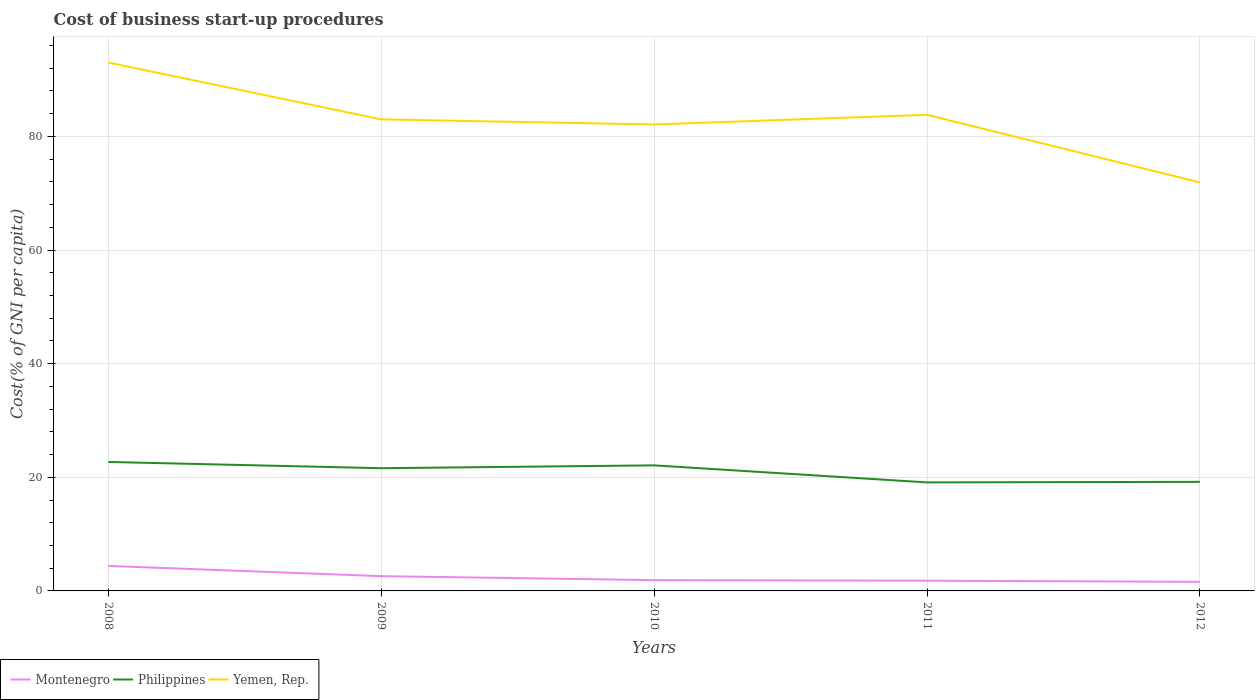Is the number of lines equal to the number of legend labels?
Make the answer very short. Yes. Across all years, what is the maximum cost of business start-up procedures in Philippines?
Your answer should be compact. 19.1. In which year was the cost of business start-up procedures in Philippines maximum?
Offer a terse response. 2011. What is the total cost of business start-up procedures in Montenegro in the graph?
Your response must be concise. 2.5. What is the difference between the highest and the second highest cost of business start-up procedures in Philippines?
Your response must be concise. 3.6. What is the difference between the highest and the lowest cost of business start-up procedures in Philippines?
Offer a very short reply. 3. How many lines are there?
Make the answer very short. 3. What is the difference between two consecutive major ticks on the Y-axis?
Make the answer very short. 20. Are the values on the major ticks of Y-axis written in scientific E-notation?
Make the answer very short. No. Does the graph contain grids?
Offer a terse response. Yes. Where does the legend appear in the graph?
Provide a succinct answer. Bottom left. How are the legend labels stacked?
Your answer should be very brief. Horizontal. What is the title of the graph?
Provide a succinct answer. Cost of business start-up procedures. What is the label or title of the Y-axis?
Offer a very short reply. Cost(% of GNI per capita). What is the Cost(% of GNI per capita) of Philippines in 2008?
Give a very brief answer. 22.7. What is the Cost(% of GNI per capita) in Yemen, Rep. in 2008?
Your response must be concise. 93. What is the Cost(% of GNI per capita) in Philippines in 2009?
Ensure brevity in your answer.  21.6. What is the Cost(% of GNI per capita) of Montenegro in 2010?
Your answer should be compact. 1.9. What is the Cost(% of GNI per capita) of Philippines in 2010?
Ensure brevity in your answer.  22.1. What is the Cost(% of GNI per capita) of Yemen, Rep. in 2010?
Give a very brief answer. 82.1. What is the Cost(% of GNI per capita) in Montenegro in 2011?
Provide a succinct answer. 1.8. What is the Cost(% of GNI per capita) of Philippines in 2011?
Your answer should be very brief. 19.1. What is the Cost(% of GNI per capita) in Yemen, Rep. in 2011?
Your answer should be very brief. 83.8. What is the Cost(% of GNI per capita) of Philippines in 2012?
Provide a succinct answer. 19.2. What is the Cost(% of GNI per capita) of Yemen, Rep. in 2012?
Give a very brief answer. 71.9. Across all years, what is the maximum Cost(% of GNI per capita) of Montenegro?
Your answer should be compact. 4.4. Across all years, what is the maximum Cost(% of GNI per capita) of Philippines?
Keep it short and to the point. 22.7. Across all years, what is the maximum Cost(% of GNI per capita) in Yemen, Rep.?
Provide a succinct answer. 93. Across all years, what is the minimum Cost(% of GNI per capita) of Montenegro?
Offer a very short reply. 1.6. Across all years, what is the minimum Cost(% of GNI per capita) in Yemen, Rep.?
Keep it short and to the point. 71.9. What is the total Cost(% of GNI per capita) of Montenegro in the graph?
Ensure brevity in your answer.  12.3. What is the total Cost(% of GNI per capita) in Philippines in the graph?
Ensure brevity in your answer.  104.7. What is the total Cost(% of GNI per capita) of Yemen, Rep. in the graph?
Your answer should be very brief. 413.8. What is the difference between the Cost(% of GNI per capita) in Yemen, Rep. in 2008 and that in 2010?
Make the answer very short. 10.9. What is the difference between the Cost(% of GNI per capita) in Philippines in 2008 and that in 2011?
Your answer should be compact. 3.6. What is the difference between the Cost(% of GNI per capita) of Yemen, Rep. in 2008 and that in 2011?
Provide a succinct answer. 9.2. What is the difference between the Cost(% of GNI per capita) of Montenegro in 2008 and that in 2012?
Ensure brevity in your answer.  2.8. What is the difference between the Cost(% of GNI per capita) in Philippines in 2008 and that in 2012?
Provide a short and direct response. 3.5. What is the difference between the Cost(% of GNI per capita) in Yemen, Rep. in 2008 and that in 2012?
Offer a terse response. 21.1. What is the difference between the Cost(% of GNI per capita) in Montenegro in 2009 and that in 2010?
Make the answer very short. 0.7. What is the difference between the Cost(% of GNI per capita) of Philippines in 2009 and that in 2010?
Offer a terse response. -0.5. What is the difference between the Cost(% of GNI per capita) of Yemen, Rep. in 2009 and that in 2010?
Keep it short and to the point. 0.9. What is the difference between the Cost(% of GNI per capita) of Philippines in 2009 and that in 2011?
Your response must be concise. 2.5. What is the difference between the Cost(% of GNI per capita) of Montenegro in 2009 and that in 2012?
Offer a terse response. 1. What is the difference between the Cost(% of GNI per capita) of Philippines in 2009 and that in 2012?
Ensure brevity in your answer.  2.4. What is the difference between the Cost(% of GNI per capita) of Montenegro in 2010 and that in 2011?
Make the answer very short. 0.1. What is the difference between the Cost(% of GNI per capita) in Philippines in 2010 and that in 2011?
Your response must be concise. 3. What is the difference between the Cost(% of GNI per capita) in Montenegro in 2010 and that in 2012?
Your answer should be compact. 0.3. What is the difference between the Cost(% of GNI per capita) of Philippines in 2010 and that in 2012?
Your response must be concise. 2.9. What is the difference between the Cost(% of GNI per capita) of Yemen, Rep. in 2010 and that in 2012?
Your response must be concise. 10.2. What is the difference between the Cost(% of GNI per capita) of Yemen, Rep. in 2011 and that in 2012?
Your answer should be very brief. 11.9. What is the difference between the Cost(% of GNI per capita) in Montenegro in 2008 and the Cost(% of GNI per capita) in Philippines in 2009?
Provide a succinct answer. -17.2. What is the difference between the Cost(% of GNI per capita) of Montenegro in 2008 and the Cost(% of GNI per capita) of Yemen, Rep. in 2009?
Your answer should be very brief. -78.6. What is the difference between the Cost(% of GNI per capita) of Philippines in 2008 and the Cost(% of GNI per capita) of Yemen, Rep. in 2009?
Give a very brief answer. -60.3. What is the difference between the Cost(% of GNI per capita) of Montenegro in 2008 and the Cost(% of GNI per capita) of Philippines in 2010?
Ensure brevity in your answer.  -17.7. What is the difference between the Cost(% of GNI per capita) of Montenegro in 2008 and the Cost(% of GNI per capita) of Yemen, Rep. in 2010?
Offer a terse response. -77.7. What is the difference between the Cost(% of GNI per capita) of Philippines in 2008 and the Cost(% of GNI per capita) of Yemen, Rep. in 2010?
Provide a succinct answer. -59.4. What is the difference between the Cost(% of GNI per capita) in Montenegro in 2008 and the Cost(% of GNI per capita) in Philippines in 2011?
Keep it short and to the point. -14.7. What is the difference between the Cost(% of GNI per capita) in Montenegro in 2008 and the Cost(% of GNI per capita) in Yemen, Rep. in 2011?
Offer a terse response. -79.4. What is the difference between the Cost(% of GNI per capita) in Philippines in 2008 and the Cost(% of GNI per capita) in Yemen, Rep. in 2011?
Your answer should be very brief. -61.1. What is the difference between the Cost(% of GNI per capita) of Montenegro in 2008 and the Cost(% of GNI per capita) of Philippines in 2012?
Your answer should be very brief. -14.8. What is the difference between the Cost(% of GNI per capita) in Montenegro in 2008 and the Cost(% of GNI per capita) in Yemen, Rep. in 2012?
Your response must be concise. -67.5. What is the difference between the Cost(% of GNI per capita) of Philippines in 2008 and the Cost(% of GNI per capita) of Yemen, Rep. in 2012?
Make the answer very short. -49.2. What is the difference between the Cost(% of GNI per capita) in Montenegro in 2009 and the Cost(% of GNI per capita) in Philippines in 2010?
Your answer should be compact. -19.5. What is the difference between the Cost(% of GNI per capita) in Montenegro in 2009 and the Cost(% of GNI per capita) in Yemen, Rep. in 2010?
Provide a short and direct response. -79.5. What is the difference between the Cost(% of GNI per capita) of Philippines in 2009 and the Cost(% of GNI per capita) of Yemen, Rep. in 2010?
Your answer should be very brief. -60.5. What is the difference between the Cost(% of GNI per capita) of Montenegro in 2009 and the Cost(% of GNI per capita) of Philippines in 2011?
Ensure brevity in your answer.  -16.5. What is the difference between the Cost(% of GNI per capita) of Montenegro in 2009 and the Cost(% of GNI per capita) of Yemen, Rep. in 2011?
Offer a terse response. -81.2. What is the difference between the Cost(% of GNI per capita) of Philippines in 2009 and the Cost(% of GNI per capita) of Yemen, Rep. in 2011?
Your response must be concise. -62.2. What is the difference between the Cost(% of GNI per capita) in Montenegro in 2009 and the Cost(% of GNI per capita) in Philippines in 2012?
Your response must be concise. -16.6. What is the difference between the Cost(% of GNI per capita) in Montenegro in 2009 and the Cost(% of GNI per capita) in Yemen, Rep. in 2012?
Offer a very short reply. -69.3. What is the difference between the Cost(% of GNI per capita) in Philippines in 2009 and the Cost(% of GNI per capita) in Yemen, Rep. in 2012?
Your response must be concise. -50.3. What is the difference between the Cost(% of GNI per capita) of Montenegro in 2010 and the Cost(% of GNI per capita) of Philippines in 2011?
Your answer should be very brief. -17.2. What is the difference between the Cost(% of GNI per capita) of Montenegro in 2010 and the Cost(% of GNI per capita) of Yemen, Rep. in 2011?
Give a very brief answer. -81.9. What is the difference between the Cost(% of GNI per capita) of Philippines in 2010 and the Cost(% of GNI per capita) of Yemen, Rep. in 2011?
Your answer should be compact. -61.7. What is the difference between the Cost(% of GNI per capita) of Montenegro in 2010 and the Cost(% of GNI per capita) of Philippines in 2012?
Provide a short and direct response. -17.3. What is the difference between the Cost(% of GNI per capita) in Montenegro in 2010 and the Cost(% of GNI per capita) in Yemen, Rep. in 2012?
Offer a very short reply. -70. What is the difference between the Cost(% of GNI per capita) of Philippines in 2010 and the Cost(% of GNI per capita) of Yemen, Rep. in 2012?
Offer a terse response. -49.8. What is the difference between the Cost(% of GNI per capita) in Montenegro in 2011 and the Cost(% of GNI per capita) in Philippines in 2012?
Offer a very short reply. -17.4. What is the difference between the Cost(% of GNI per capita) in Montenegro in 2011 and the Cost(% of GNI per capita) in Yemen, Rep. in 2012?
Your answer should be very brief. -70.1. What is the difference between the Cost(% of GNI per capita) in Philippines in 2011 and the Cost(% of GNI per capita) in Yemen, Rep. in 2012?
Offer a terse response. -52.8. What is the average Cost(% of GNI per capita) in Montenegro per year?
Your answer should be compact. 2.46. What is the average Cost(% of GNI per capita) of Philippines per year?
Give a very brief answer. 20.94. What is the average Cost(% of GNI per capita) of Yemen, Rep. per year?
Your answer should be very brief. 82.76. In the year 2008, what is the difference between the Cost(% of GNI per capita) of Montenegro and Cost(% of GNI per capita) of Philippines?
Keep it short and to the point. -18.3. In the year 2008, what is the difference between the Cost(% of GNI per capita) in Montenegro and Cost(% of GNI per capita) in Yemen, Rep.?
Offer a very short reply. -88.6. In the year 2008, what is the difference between the Cost(% of GNI per capita) of Philippines and Cost(% of GNI per capita) of Yemen, Rep.?
Provide a short and direct response. -70.3. In the year 2009, what is the difference between the Cost(% of GNI per capita) of Montenegro and Cost(% of GNI per capita) of Yemen, Rep.?
Give a very brief answer. -80.4. In the year 2009, what is the difference between the Cost(% of GNI per capita) in Philippines and Cost(% of GNI per capita) in Yemen, Rep.?
Make the answer very short. -61.4. In the year 2010, what is the difference between the Cost(% of GNI per capita) of Montenegro and Cost(% of GNI per capita) of Philippines?
Provide a short and direct response. -20.2. In the year 2010, what is the difference between the Cost(% of GNI per capita) of Montenegro and Cost(% of GNI per capita) of Yemen, Rep.?
Offer a terse response. -80.2. In the year 2010, what is the difference between the Cost(% of GNI per capita) in Philippines and Cost(% of GNI per capita) in Yemen, Rep.?
Offer a terse response. -60. In the year 2011, what is the difference between the Cost(% of GNI per capita) in Montenegro and Cost(% of GNI per capita) in Philippines?
Provide a short and direct response. -17.3. In the year 2011, what is the difference between the Cost(% of GNI per capita) of Montenegro and Cost(% of GNI per capita) of Yemen, Rep.?
Give a very brief answer. -82. In the year 2011, what is the difference between the Cost(% of GNI per capita) in Philippines and Cost(% of GNI per capita) in Yemen, Rep.?
Make the answer very short. -64.7. In the year 2012, what is the difference between the Cost(% of GNI per capita) in Montenegro and Cost(% of GNI per capita) in Philippines?
Provide a short and direct response. -17.6. In the year 2012, what is the difference between the Cost(% of GNI per capita) in Montenegro and Cost(% of GNI per capita) in Yemen, Rep.?
Offer a terse response. -70.3. In the year 2012, what is the difference between the Cost(% of GNI per capita) in Philippines and Cost(% of GNI per capita) in Yemen, Rep.?
Your response must be concise. -52.7. What is the ratio of the Cost(% of GNI per capita) in Montenegro in 2008 to that in 2009?
Keep it short and to the point. 1.69. What is the ratio of the Cost(% of GNI per capita) in Philippines in 2008 to that in 2009?
Offer a terse response. 1.05. What is the ratio of the Cost(% of GNI per capita) in Yemen, Rep. in 2008 to that in 2009?
Ensure brevity in your answer.  1.12. What is the ratio of the Cost(% of GNI per capita) in Montenegro in 2008 to that in 2010?
Make the answer very short. 2.32. What is the ratio of the Cost(% of GNI per capita) of Philippines in 2008 to that in 2010?
Provide a short and direct response. 1.03. What is the ratio of the Cost(% of GNI per capita) of Yemen, Rep. in 2008 to that in 2010?
Offer a terse response. 1.13. What is the ratio of the Cost(% of GNI per capita) in Montenegro in 2008 to that in 2011?
Your response must be concise. 2.44. What is the ratio of the Cost(% of GNI per capita) of Philippines in 2008 to that in 2011?
Make the answer very short. 1.19. What is the ratio of the Cost(% of GNI per capita) in Yemen, Rep. in 2008 to that in 2011?
Offer a terse response. 1.11. What is the ratio of the Cost(% of GNI per capita) of Montenegro in 2008 to that in 2012?
Keep it short and to the point. 2.75. What is the ratio of the Cost(% of GNI per capita) of Philippines in 2008 to that in 2012?
Keep it short and to the point. 1.18. What is the ratio of the Cost(% of GNI per capita) of Yemen, Rep. in 2008 to that in 2012?
Ensure brevity in your answer.  1.29. What is the ratio of the Cost(% of GNI per capita) in Montenegro in 2009 to that in 2010?
Offer a very short reply. 1.37. What is the ratio of the Cost(% of GNI per capita) of Philippines in 2009 to that in 2010?
Your answer should be very brief. 0.98. What is the ratio of the Cost(% of GNI per capita) in Yemen, Rep. in 2009 to that in 2010?
Give a very brief answer. 1.01. What is the ratio of the Cost(% of GNI per capita) in Montenegro in 2009 to that in 2011?
Keep it short and to the point. 1.44. What is the ratio of the Cost(% of GNI per capita) of Philippines in 2009 to that in 2011?
Ensure brevity in your answer.  1.13. What is the ratio of the Cost(% of GNI per capita) of Montenegro in 2009 to that in 2012?
Provide a succinct answer. 1.62. What is the ratio of the Cost(% of GNI per capita) of Philippines in 2009 to that in 2012?
Offer a terse response. 1.12. What is the ratio of the Cost(% of GNI per capita) of Yemen, Rep. in 2009 to that in 2012?
Give a very brief answer. 1.15. What is the ratio of the Cost(% of GNI per capita) of Montenegro in 2010 to that in 2011?
Provide a succinct answer. 1.06. What is the ratio of the Cost(% of GNI per capita) in Philippines in 2010 to that in 2011?
Provide a short and direct response. 1.16. What is the ratio of the Cost(% of GNI per capita) of Yemen, Rep. in 2010 to that in 2011?
Provide a short and direct response. 0.98. What is the ratio of the Cost(% of GNI per capita) of Montenegro in 2010 to that in 2012?
Make the answer very short. 1.19. What is the ratio of the Cost(% of GNI per capita) in Philippines in 2010 to that in 2012?
Offer a terse response. 1.15. What is the ratio of the Cost(% of GNI per capita) in Yemen, Rep. in 2010 to that in 2012?
Provide a short and direct response. 1.14. What is the ratio of the Cost(% of GNI per capita) of Philippines in 2011 to that in 2012?
Your answer should be very brief. 0.99. What is the ratio of the Cost(% of GNI per capita) of Yemen, Rep. in 2011 to that in 2012?
Make the answer very short. 1.17. What is the difference between the highest and the second highest Cost(% of GNI per capita) in Montenegro?
Provide a short and direct response. 1.8. What is the difference between the highest and the lowest Cost(% of GNI per capita) of Montenegro?
Your answer should be very brief. 2.8. What is the difference between the highest and the lowest Cost(% of GNI per capita) of Philippines?
Provide a succinct answer. 3.6. What is the difference between the highest and the lowest Cost(% of GNI per capita) in Yemen, Rep.?
Your response must be concise. 21.1. 